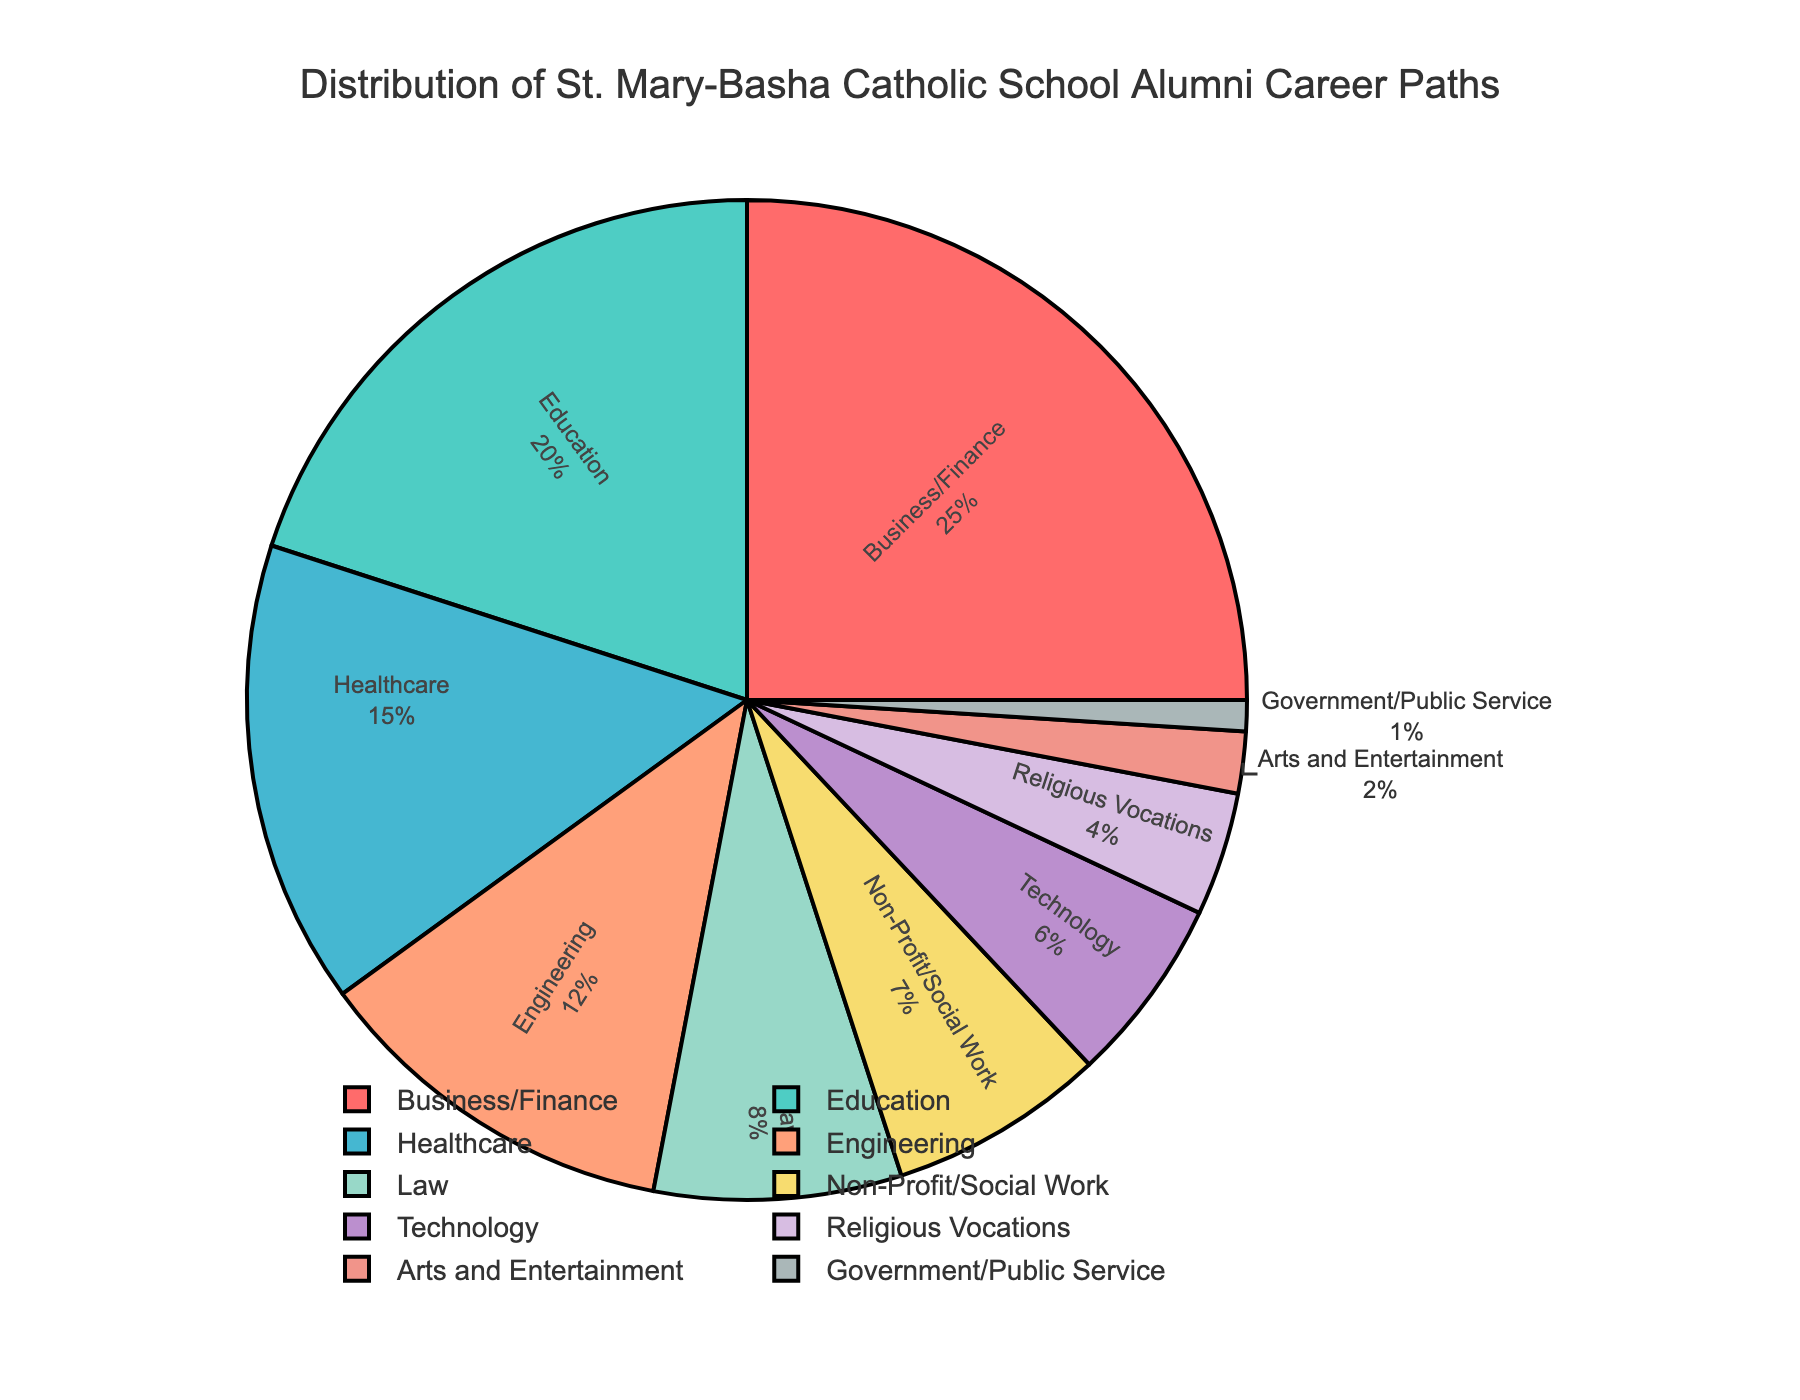Which career path has the highest percentage of alumni? The pie chart shows that Business/Finance has the largest segment.
Answer: Business/Finance What combined percentage of alumni are in Healthcare, Engineering, and Technology fields? Add the percentages for Healthcare (15%), Engineering (12%), and Technology (6%): 15 + 12 + 6 = 33%.
Answer: 33% Compare the percentage of alumni in Education to those in Government/Public Service. Which is higher? The pie chart shows Education at 20% and Government/Public Service at 1%. Education is higher.
Answer: Education How does the percentage of alumni in Religious Vocations compare to those in Arts and Entertainment? Religious Vocations are at 4% and Arts and Entertainment are at 2%, so Religious Vocations is higher.
Answer: Religious Vocations What's the combined percentage of alumni in Law and Non-Profit/Social Work fields? Add the percentages for Law (8%) and Non-Profit/Social Work (7%): 8 + 7 = 15%.
Answer: 15% Which career path has the smallest representation among alumni? Look for the smallest segment in the pie chart, which is Government/Public Service at 1%.
Answer: Government/Public Service What is the percentage difference between Business/Finance and Education? Subtract Business/Finance (25%) and Education (20%): 25 - 20 = 5%.
Answer: 5% How many career paths have percentages that are less than 10%? The pie chart includes Law (8%), Non-Profit/Social Work (7%), Technology (6%), Religious Vocations (4%), Arts and Entertainment (2%), and Government/Public Service (1%). Six career paths are below 10%.
Answer: 6 Which career paths together make up half or more of the alumni? Add Business/Finance (25%) and Education (20%) to get 25 + 20 = 45%, and then add Healthcare (15%) to get 45 + 15 = 60%. These three make up more than half.
Answer: Business/Finance, Education, Healthcare 